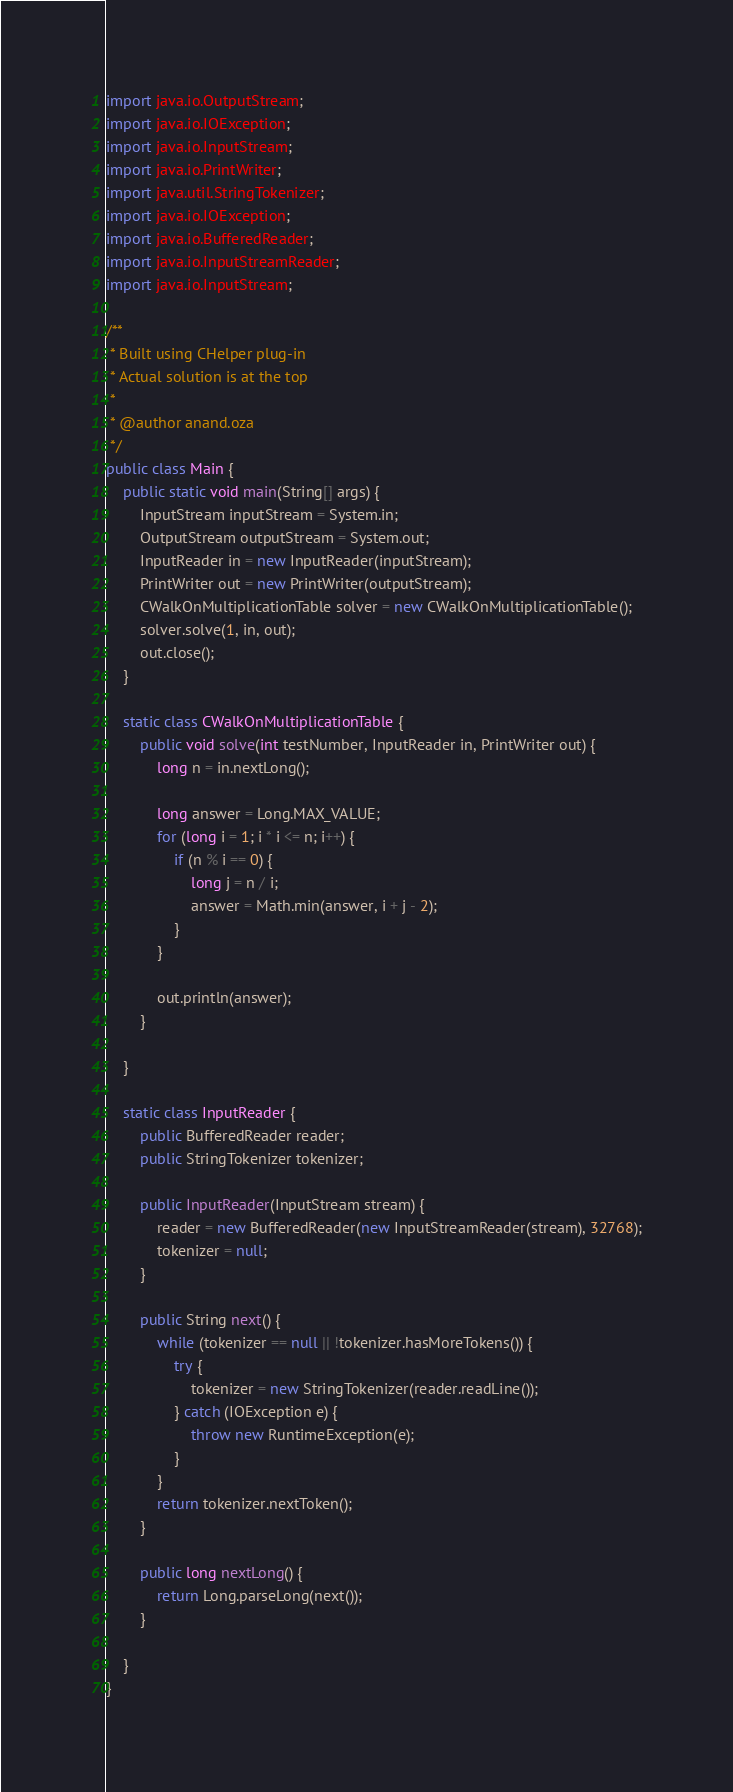<code> <loc_0><loc_0><loc_500><loc_500><_Java_>import java.io.OutputStream;
import java.io.IOException;
import java.io.InputStream;
import java.io.PrintWriter;
import java.util.StringTokenizer;
import java.io.IOException;
import java.io.BufferedReader;
import java.io.InputStreamReader;
import java.io.InputStream;

/**
 * Built using CHelper plug-in
 * Actual solution is at the top
 *
 * @author anand.oza
 */
public class Main {
    public static void main(String[] args) {
        InputStream inputStream = System.in;
        OutputStream outputStream = System.out;
        InputReader in = new InputReader(inputStream);
        PrintWriter out = new PrintWriter(outputStream);
        CWalkOnMultiplicationTable solver = new CWalkOnMultiplicationTable();
        solver.solve(1, in, out);
        out.close();
    }

    static class CWalkOnMultiplicationTable {
        public void solve(int testNumber, InputReader in, PrintWriter out) {
            long n = in.nextLong();

            long answer = Long.MAX_VALUE;
            for (long i = 1; i * i <= n; i++) {
                if (n % i == 0) {
                    long j = n / i;
                    answer = Math.min(answer, i + j - 2);
                }
            }

            out.println(answer);
        }

    }

    static class InputReader {
        public BufferedReader reader;
        public StringTokenizer tokenizer;

        public InputReader(InputStream stream) {
            reader = new BufferedReader(new InputStreamReader(stream), 32768);
            tokenizer = null;
        }

        public String next() {
            while (tokenizer == null || !tokenizer.hasMoreTokens()) {
                try {
                    tokenizer = new StringTokenizer(reader.readLine());
                } catch (IOException e) {
                    throw new RuntimeException(e);
                }
            }
            return tokenizer.nextToken();
        }

        public long nextLong() {
            return Long.parseLong(next());
        }

    }
}

</code> 